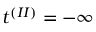Convert formula to latex. <formula><loc_0><loc_0><loc_500><loc_500>t ^ { ( I I ) } = - \infty</formula> 